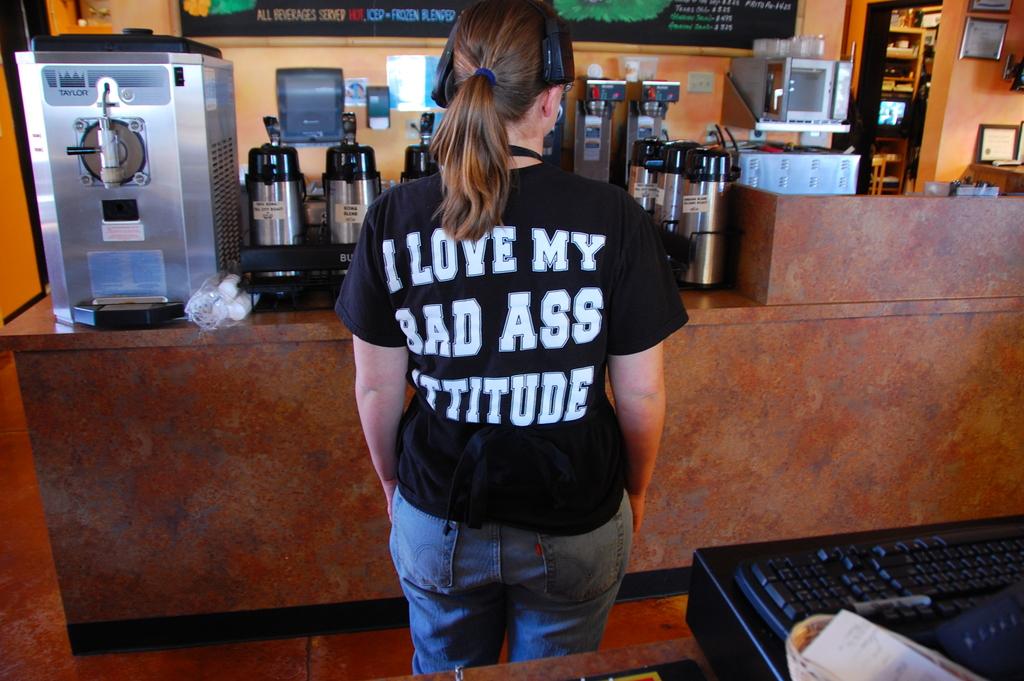What does the girl love?
Provide a short and direct response. Her bad ass attitude. What is the brand of the beverage machine behind the girl?
Ensure brevity in your answer.  Taylor. 